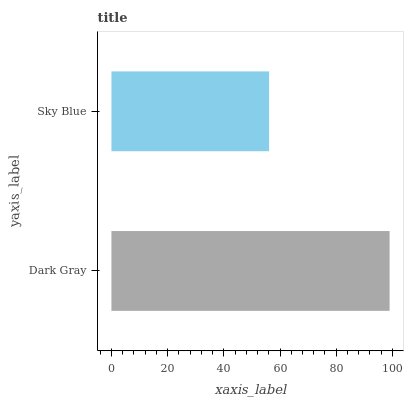Is Sky Blue the minimum?
Answer yes or no. Yes. Is Dark Gray the maximum?
Answer yes or no. Yes. Is Sky Blue the maximum?
Answer yes or no. No. Is Dark Gray greater than Sky Blue?
Answer yes or no. Yes. Is Sky Blue less than Dark Gray?
Answer yes or no. Yes. Is Sky Blue greater than Dark Gray?
Answer yes or no. No. Is Dark Gray less than Sky Blue?
Answer yes or no. No. Is Dark Gray the high median?
Answer yes or no. Yes. Is Sky Blue the low median?
Answer yes or no. Yes. Is Sky Blue the high median?
Answer yes or no. No. Is Dark Gray the low median?
Answer yes or no. No. 